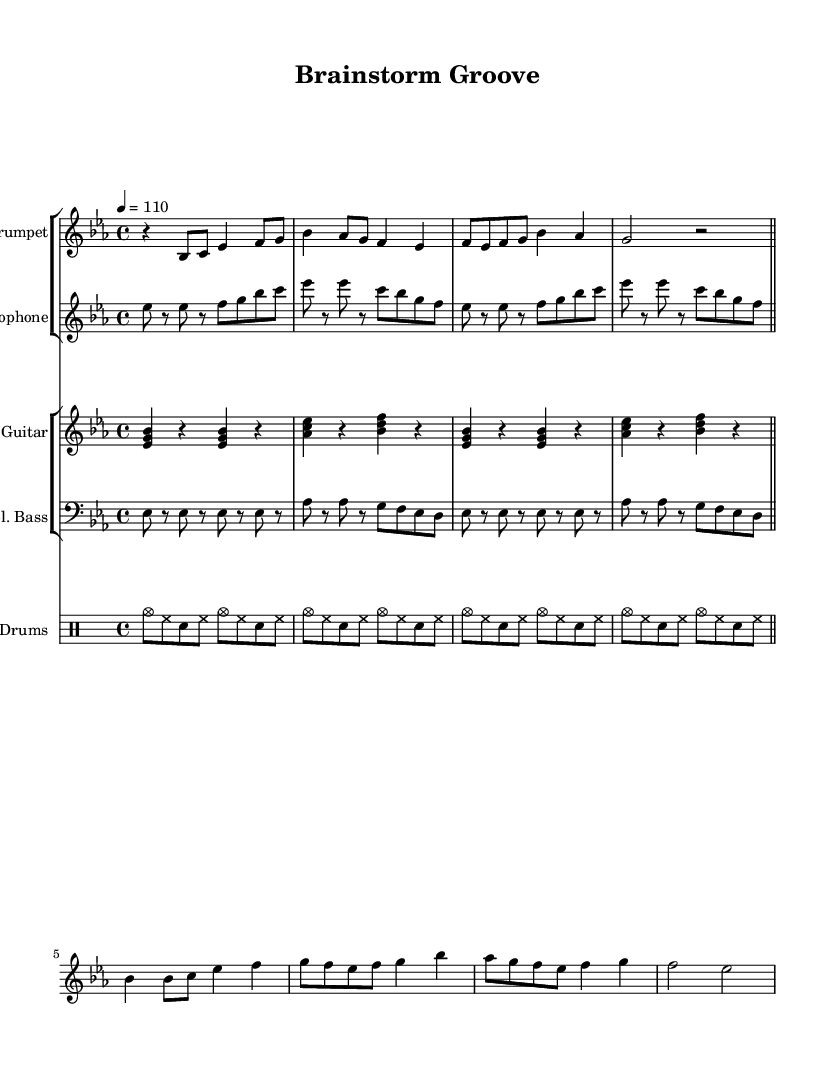What is the key signature of this music? The key signature is E flat major, which has three flat notes (B flat, E flat, and A flat).
Answer: E flat major What is the time signature of this music? The time signature is represented at the beginning of the music, indicating how many beats are in a measure and the note value that gets the beat. In this case, it shows that there are four beats per measure, which is common in funk music.
Answer: 4/4 What is the tempo marking of this piece? The tempo marking is indicated with a number and an equals sign, which specifies the beats per minute. In this example, it shows a speed of 110 beats per minute.
Answer: 110 How many measures are in the trumpet part? By counting the number of lines and the measures within them, we find that the trumpet part contains a total of eight measures.
Answer: 8 What is the role of the brass sections in this funk piece? The brass sections, consisting of the trumpet and saxophone, primarily provide melodic lines and riffs that enhance the upbeat and lively nature of funk music, contributing to the overall groove and creativity during brainstorming sessions.
Answer: Melody and riffs How many different instrumental sections are there in the score? The score is divided into two main groups: the brass group (trumpet and saxophone) and the rhythm section (electric guitar, electric bass, and drums). Counting the group divisions gives a total of three different instrumental sections in the score.
Answer: 3 What pattern is repeated in the drums part? The drumming part contains a consistent pattern where the cymbals and snare are alternated with hi-hat, creating a steady groove that is characteristic of funk music. This pattern repeats for four measures, demonstrating a strong rhythmic foundation.
Answer: Steady groove 